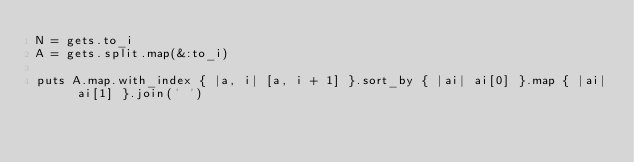<code> <loc_0><loc_0><loc_500><loc_500><_Ruby_>N = gets.to_i
A = gets.split.map(&:to_i)

puts A.map.with_index { |a, i| [a, i + 1] }.sort_by { |ai| ai[0] }.map { |ai| ai[1] }.join(' ')
</code> 